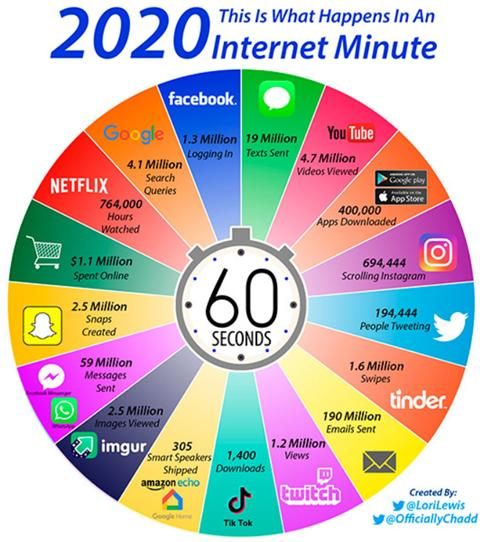Indicate a few pertinent items in this graphic. In the last two minutes, there have been 1,388,888 people scrolling on Instagram. It is estimated that approximately 800,000 apps are downloaded in 2 minutes. It is estimated that approximately 5 million snapchats are created in just two minutes. It is estimated that approximately 5 million images are viewed in 2 minutes. Approximately 2.6 million people are logging into Facebook in 2 minutes. 